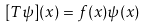Convert formula to latex. <formula><loc_0><loc_0><loc_500><loc_500>[ T \psi ] ( x ) = f ( x ) \psi ( x )</formula> 